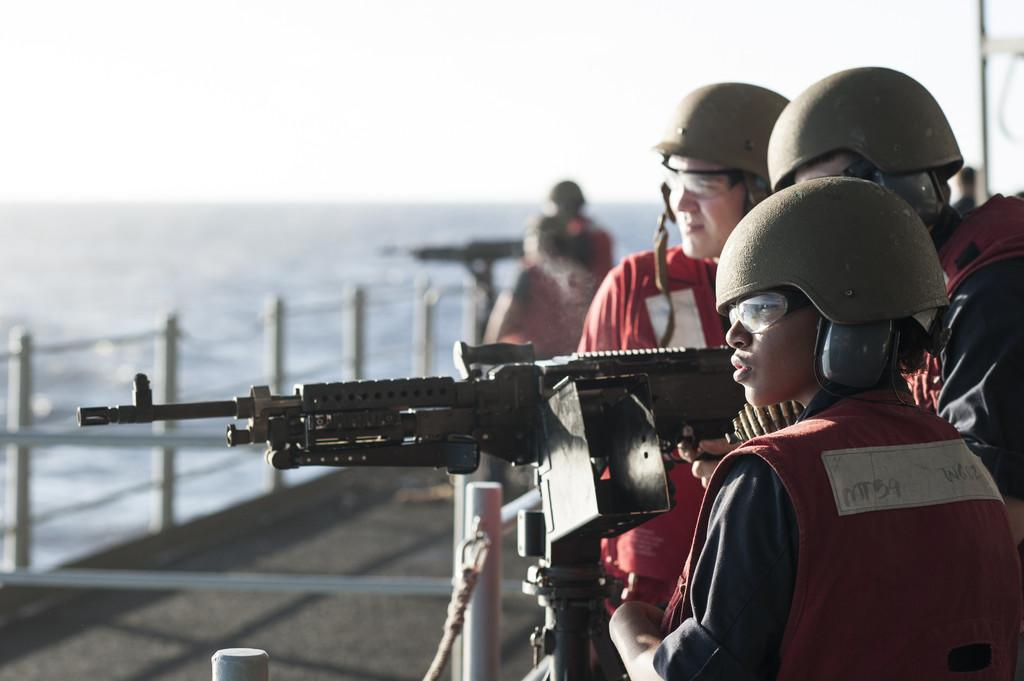What can be seen on the right side of the image? There are people standing at the right side of the image. What are the people wearing? The people are wearing helmets. What is visible in the background of the image? There is a sea visible in the background of the image. What is visible at the top of the image? The sky is visible at the top of the image. Where is the orange tree located in the image? There is no orange tree present in the image. What type of park can be seen in the image? There is no park visible in the image. 